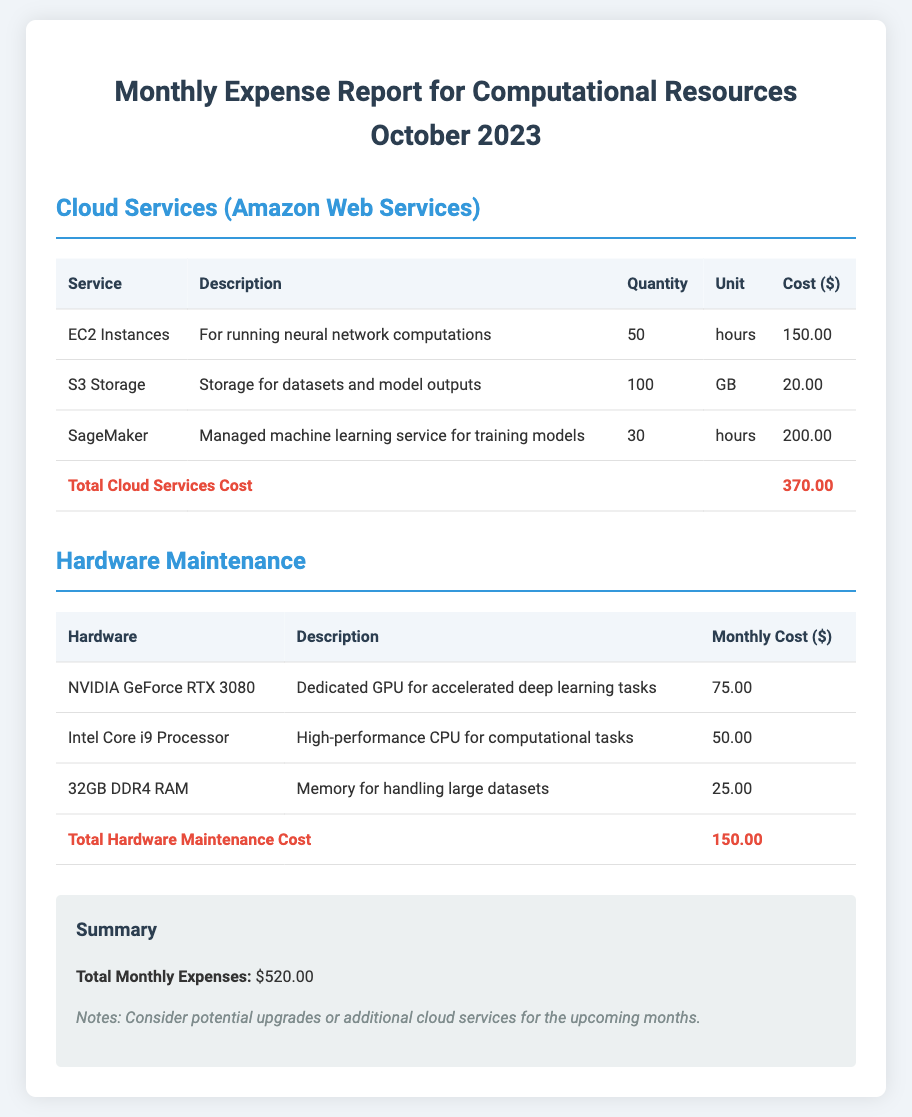What is the total cost for cloud services? The total cost for cloud services is provided in the document, which sums up the costs of different services.
Answer: 370.00 How many hours of EC2 Instances were utilized? The document states the quantity used for EC2 Instances, which is specified in hours.
Answer: 50 What is the monthly cost for the NVIDIA GeForce RTX 3080? The document lists the monthly cost for the NVIDIA GeForce RTX 3080 under Hardware Maintenance.
Answer: 75.00 What is the total monthly expense? The document provides a summary that lists the total monthly expenses at the end.
Answer: 520.00 How much did SageMaker cost? The document provides the specific cost associated with using SageMaker for the thesis project.
Answer: 200.00 What is the description of S3 Storage? The description for S3 Storage is included in the table that outlines cloud services.
Answer: Storage for datasets and model outputs What is the total hardware maintenance cost? The document specifically sums up the costs of all hardware maintenance in a designated total row.
Answer: 150.00 How many gigabytes of S3 Storage were used? The document states the quantity utilized for S3 Storage, measured in gigabytes.
Answer: 100 Which processor is indicated in the hardware maintenance section? The hardware maintenance section lists the processors used for computational tasks.
Answer: Intel Core i9 Processor 